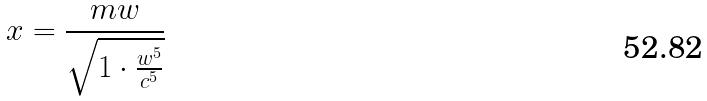Convert formula to latex. <formula><loc_0><loc_0><loc_500><loc_500>x = \frac { m w } { \sqrt { 1 \cdot \frac { w ^ { 5 } } { c ^ { 5 } } } }</formula> 